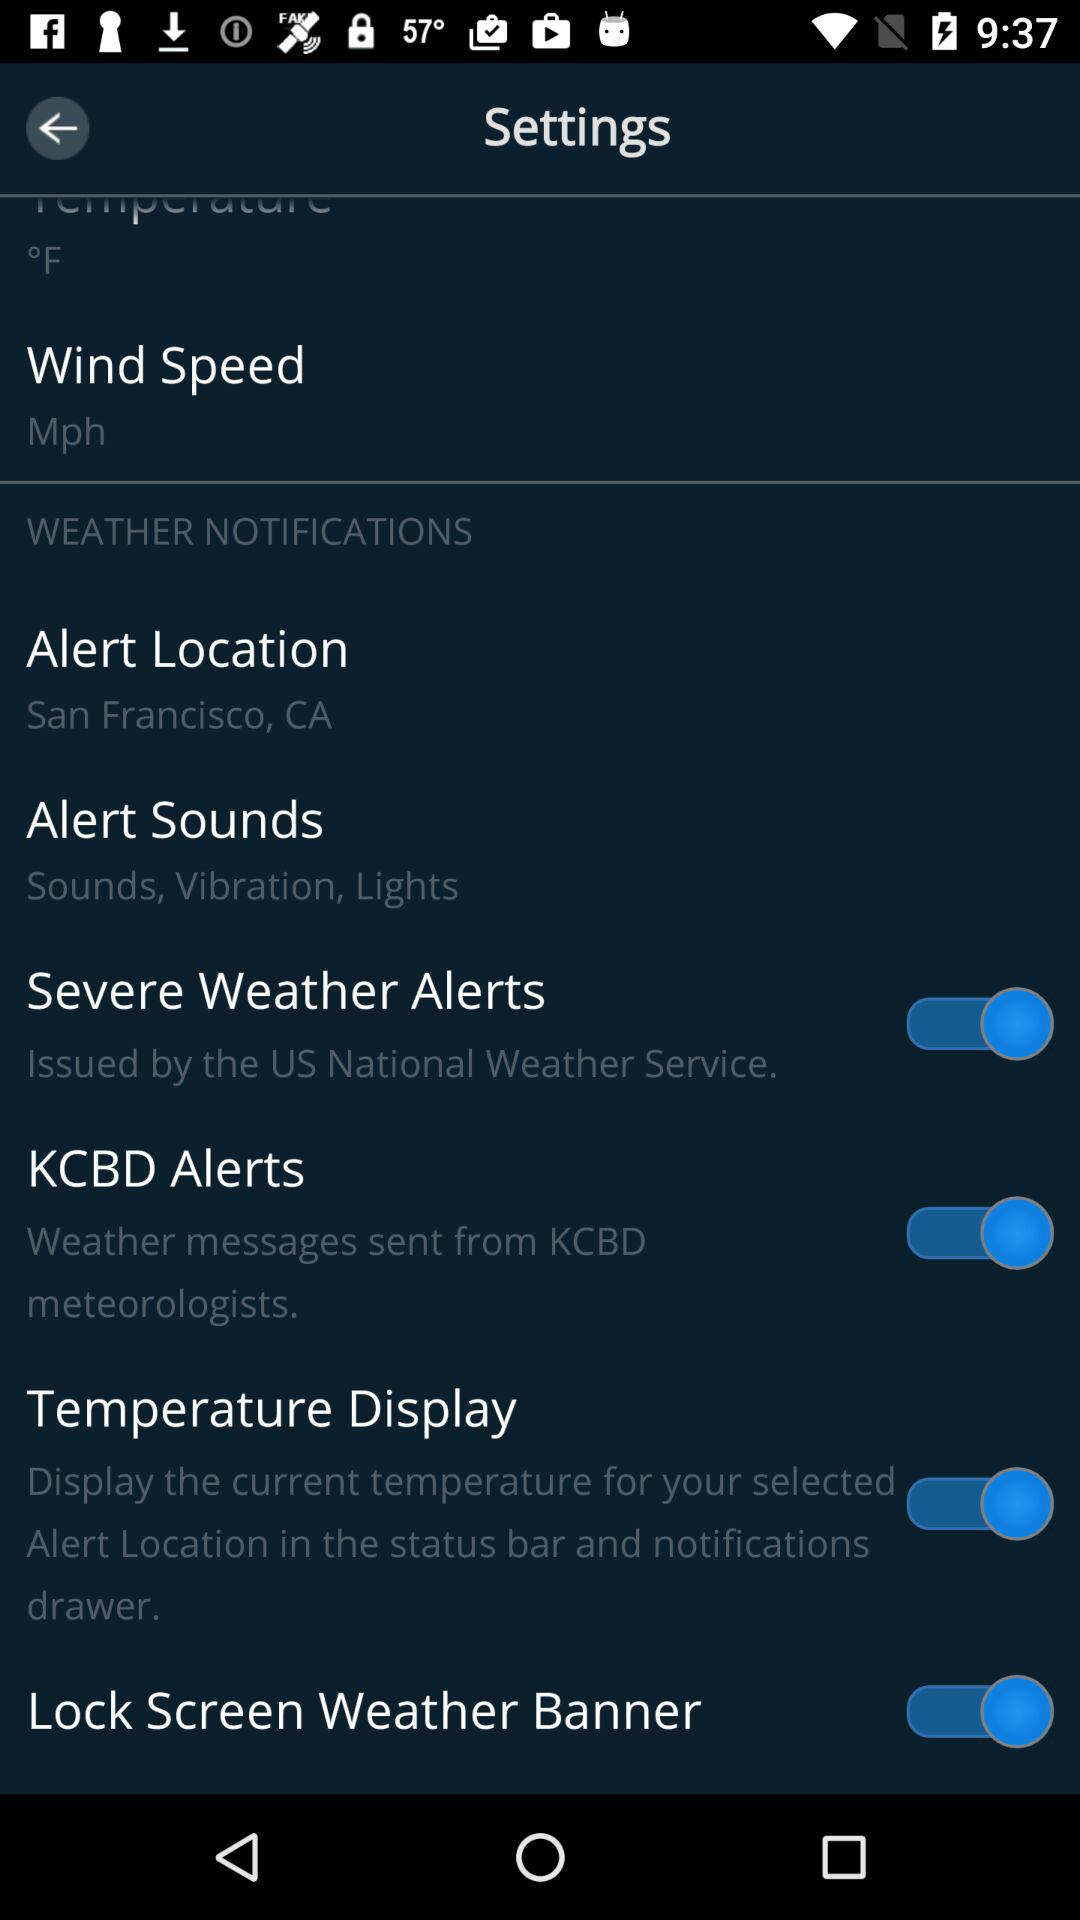Who sent the weather message? The weather message is sent by KCBD meteorologists. 